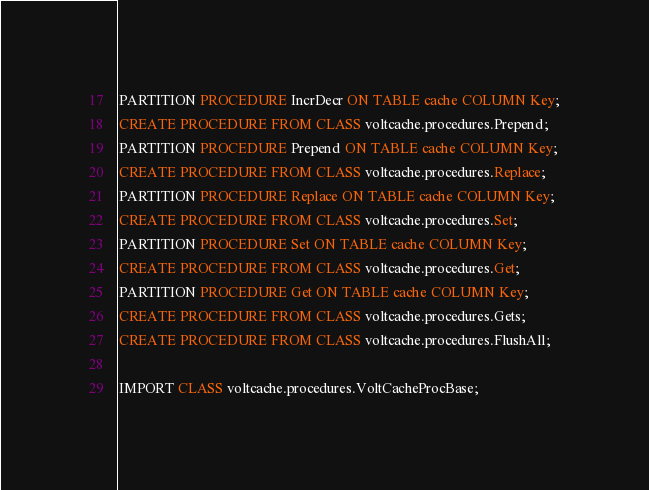Convert code to text. <code><loc_0><loc_0><loc_500><loc_500><_SQL_>PARTITION PROCEDURE IncrDecr ON TABLE cache COLUMN Key;
CREATE PROCEDURE FROM CLASS voltcache.procedures.Prepend;
PARTITION PROCEDURE Prepend ON TABLE cache COLUMN Key;
CREATE PROCEDURE FROM CLASS voltcache.procedures.Replace;
PARTITION PROCEDURE Replace ON TABLE cache COLUMN Key;
CREATE PROCEDURE FROM CLASS voltcache.procedures.Set;
PARTITION PROCEDURE Set ON TABLE cache COLUMN Key;
CREATE PROCEDURE FROM CLASS voltcache.procedures.Get;
PARTITION PROCEDURE Get ON TABLE cache COLUMN Key;
CREATE PROCEDURE FROM CLASS voltcache.procedures.Gets;
CREATE PROCEDURE FROM CLASS voltcache.procedures.FlushAll;

IMPORT CLASS voltcache.procedures.VoltCacheProcBase;
</code> 